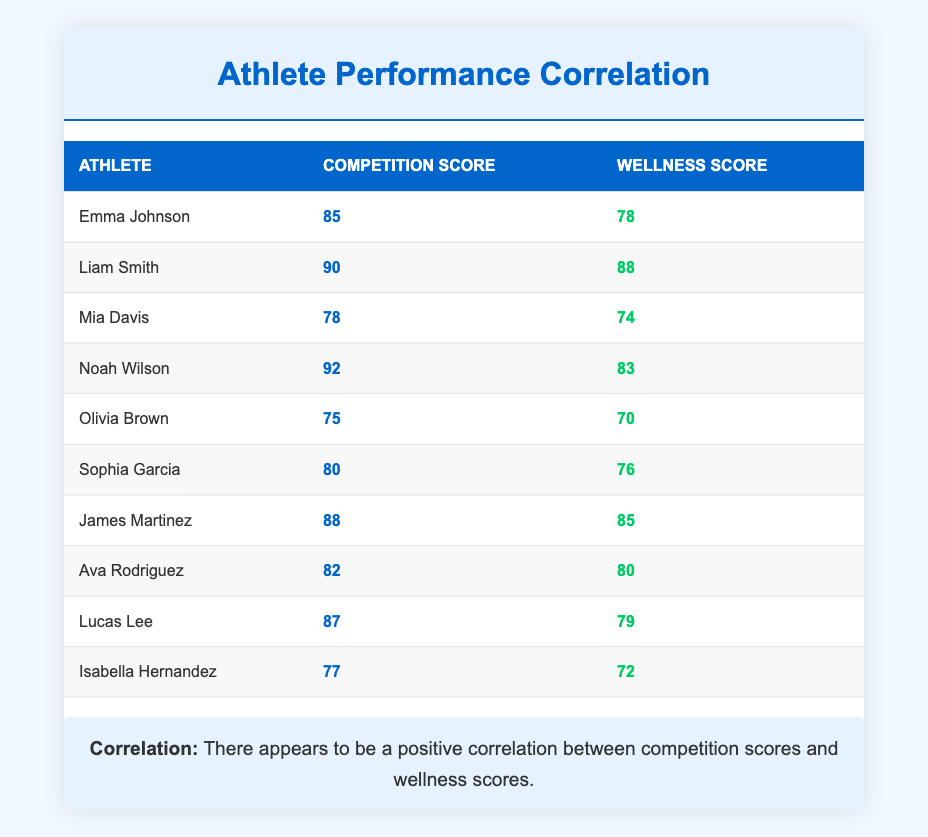What is the competition score of Liam Smith? Liam Smith is listed in the table under the athletes, and his corresponding competition score is 90.
Answer: 90 Which athlete has the highest wellness score? To find the highest wellness score, we look at the wellness scores in the table, which include 78, 88, 74, 83, 70, 76, 85, 80, 79, and 72. The maximum value among these is 88, attributed to Liam Smith.
Answer: Liam Smith What is the average competition score of all athletes? We calculate the average competition score by first summing all the competition scores: (85 + 90 + 78 + 92 + 75 + 80 + 88 + 82 + 87 + 77) = 834. There are 10 athletes, so the average is 834 / 10 = 83.4.
Answer: 83.4 Is there an athlete with a wellness score below 75? Reviewing the wellness scores, we have 78, 88, 74, 83, 70, 76, 85, 80, 79, and 72. We see that Mia Davis has a score of 74 and Olivia Brown has a score of 70, both below 75. Thus, the answer is yes.
Answer: Yes Which athlete has the lowest competition score? By inspecting the competition scores, which are 85, 90, 78, 92, 75, 80, 88, 82, 87, and 77, we find that the minimum score is 75 attributed to Olivia Brown.
Answer: Olivia Brown What is the difference between the highest and lowest wellness scores? The highest wellness score is 88 (Liam Smith) and the lowest is 70 (Olivia Brown). To find the difference, we subtract the lowest from the highest: 88 - 70 = 18.
Answer: 18 Do any athletes have the same competition score? Looking through the competition scores, each athlete has a different score: 85, 90, 78, 92, 75, 80, 88, 82, 87, and 77. No scores are repeated. Therefore, the answer is no.
Answer: No Which athlete has the highest competition and wellness scores combined? We will sum the competition and wellness scores for each athlete: for instance, for Liam Smith: 90 + 88 = 178. We do this for all athletes: Emma (163), Liam (178), Mia (152), Noah (175), Olivia (145), Sophia (156), James (173), Ava (162), Lucas (166), Isabella (149). The highest combined score is 178 for Liam Smith.
Answer: Liam Smith What is the combined score of the athlete with the second-highest wellness score? James Martinez has the second-highest wellness score of 85. His competition score is 88. So, we add: 85 + 88 = 173.
Answer: 173 